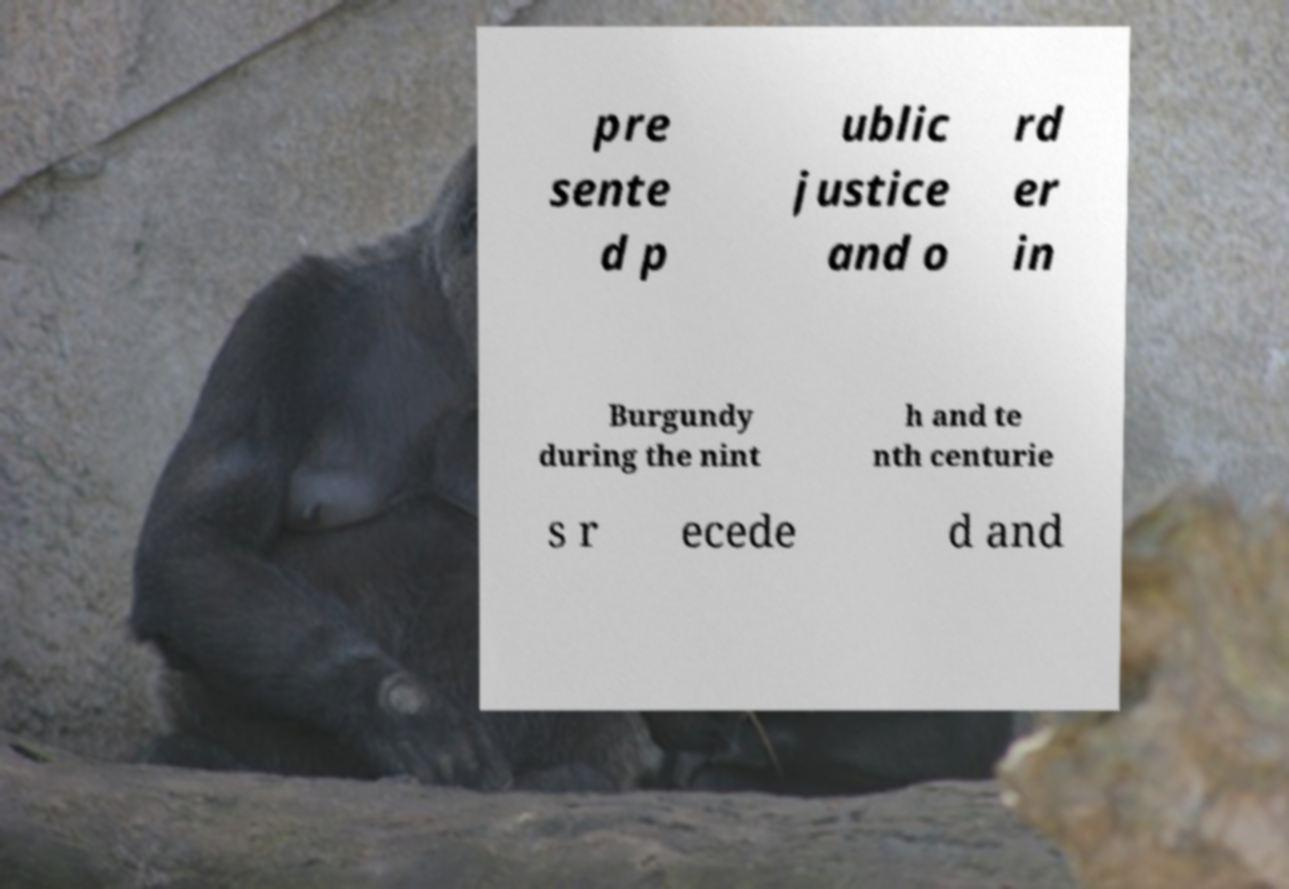For documentation purposes, I need the text within this image transcribed. Could you provide that? pre sente d p ublic justice and o rd er in Burgundy during the nint h and te nth centurie s r ecede d and 